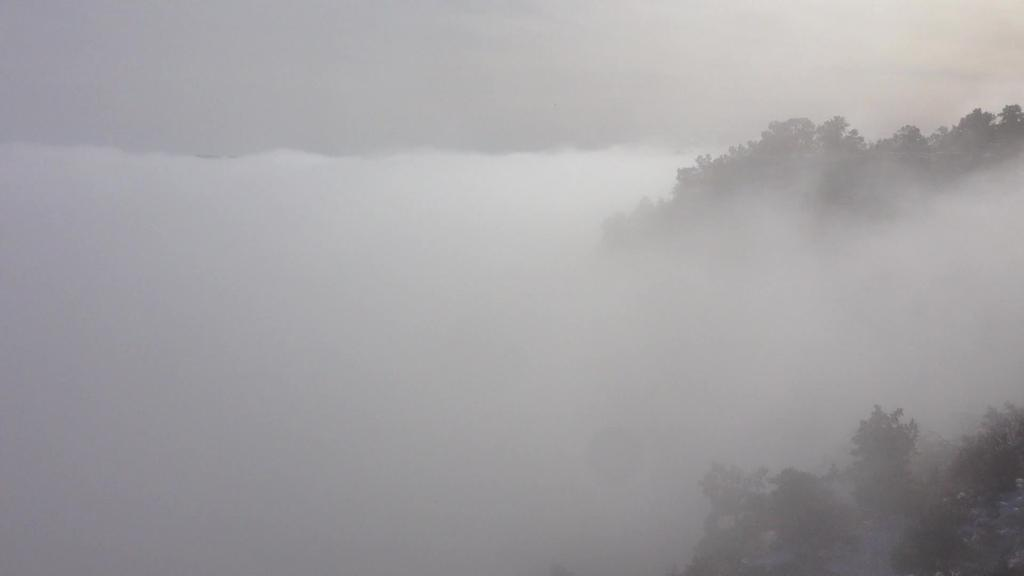What is the primary feature of the landscape in the image? There is snow in the image. What type of vegetation can be seen on the right side of the image? There are trees on the right side of the image. What type of brass instrument is being played by the bird in the image? There is no brass instrument or bird present in the image. What rule is being enforced by the snow in the image? The snow in the image is not enforcing any rules; it is simply a natural feature of the landscape. 